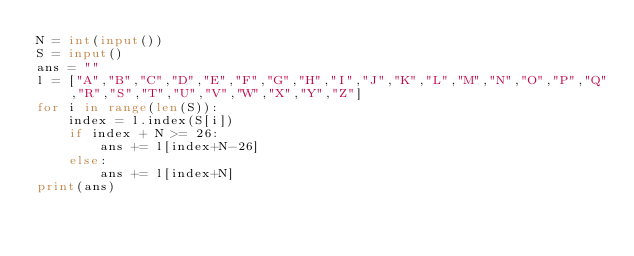Convert code to text. <code><loc_0><loc_0><loc_500><loc_500><_Python_>N = int(input())
S = input()
ans = ""
l = ["A","B","C","D","E","F","G","H","I","J","K","L","M","N","O","P","Q","R","S","T","U","V","W","X","Y","Z"]
for i in range(len(S)):
    index = l.index(S[i])
    if index + N >= 26:
        ans += l[index+N-26]
    else:
        ans += l[index+N]
print(ans)</code> 